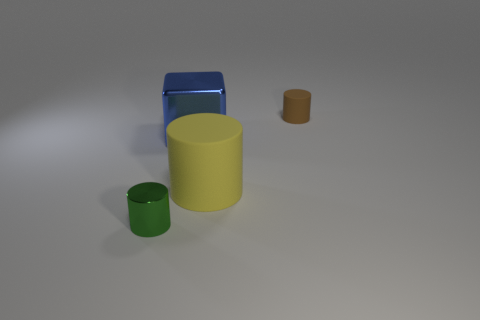Subtract all purple cylinders. Subtract all cyan spheres. How many cylinders are left? 3 Add 4 green objects. How many objects exist? 8 Subtract all cylinders. How many objects are left? 1 Add 1 tiny brown matte things. How many tiny brown matte things exist? 2 Subtract 0 red cubes. How many objects are left? 4 Subtract all brown matte objects. Subtract all big matte cylinders. How many objects are left? 2 Add 2 big yellow cylinders. How many big yellow cylinders are left? 3 